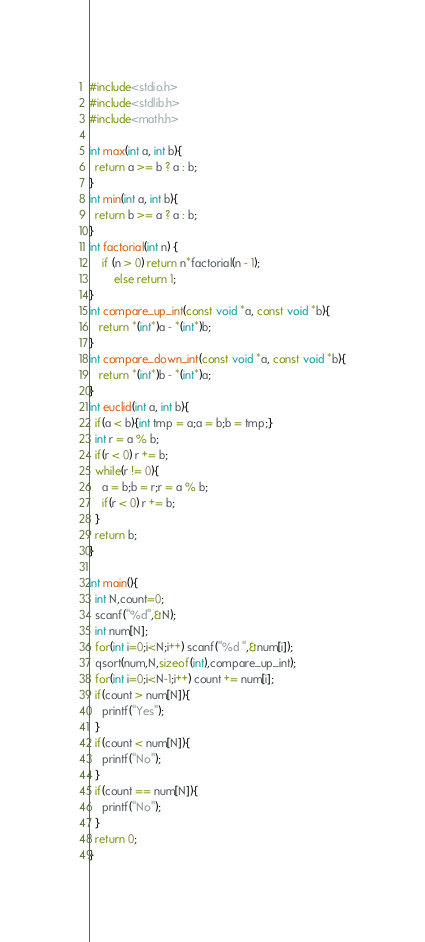Convert code to text. <code><loc_0><loc_0><loc_500><loc_500><_C_>#include<stdio.h>
#include<stdlib.h>
#include<math.h>

int max(int a, int b){
  return a >= b ? a : b;
}
int min(int a, int b){
  return b >= a ? a : b;
}
int factorial(int n) {
    if (n > 0) return n*factorial(n - 1);
		else return 1;
}
int compare_up_int(const void *a, const void *b){
   return *(int*)a - *(int*)b;
}
int compare_down_int(const void *a, const void *b){
   return *(int*)b - *(int*)a;
}
int euclid(int a, int b){
  if(a < b){int tmp = a;a = b;b = tmp;}
  int r = a % b;
  if(r < 0) r += b;
  while(r != 0){
    a = b;b = r;r = a % b;
    if(r < 0) r += b;
  }
  return b;
}

int main(){
  int N,count=0;
  scanf("%d",&N);
  int num[N];
  for(int i=0;i<N;i++) scanf("%d ",&num[i]);
  qsort(num,N,sizeof(int),compare_up_int);
  for(int i=0;i<N-1;i++) count += num[i];
  if(count > num[N]){
    printf("Yes");
  }
  if(count < num[N]){
    printf("No");
  }
  if(count == num[N]){
    printf("No");
  }
  return 0;
}
</code> 